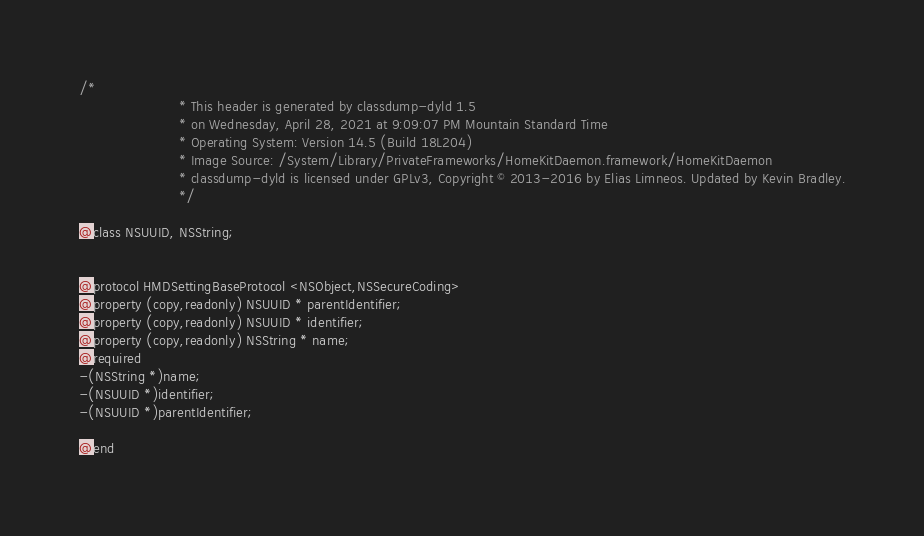Convert code to text. <code><loc_0><loc_0><loc_500><loc_500><_C_>/*
                       * This header is generated by classdump-dyld 1.5
                       * on Wednesday, April 28, 2021 at 9:09:07 PM Mountain Standard Time
                       * Operating System: Version 14.5 (Build 18L204)
                       * Image Source: /System/Library/PrivateFrameworks/HomeKitDaemon.framework/HomeKitDaemon
                       * classdump-dyld is licensed under GPLv3, Copyright © 2013-2016 by Elias Limneos. Updated by Kevin Bradley.
                       */

@class NSUUID, NSString;


@protocol HMDSettingBaseProtocol <NSObject,NSSecureCoding>
@property (copy,readonly) NSUUID * parentIdentifier; 
@property (copy,readonly) NSUUID * identifier; 
@property (copy,readonly) NSString * name; 
@required
-(NSString *)name;
-(NSUUID *)identifier;
-(NSUUID *)parentIdentifier;

@end

</code> 